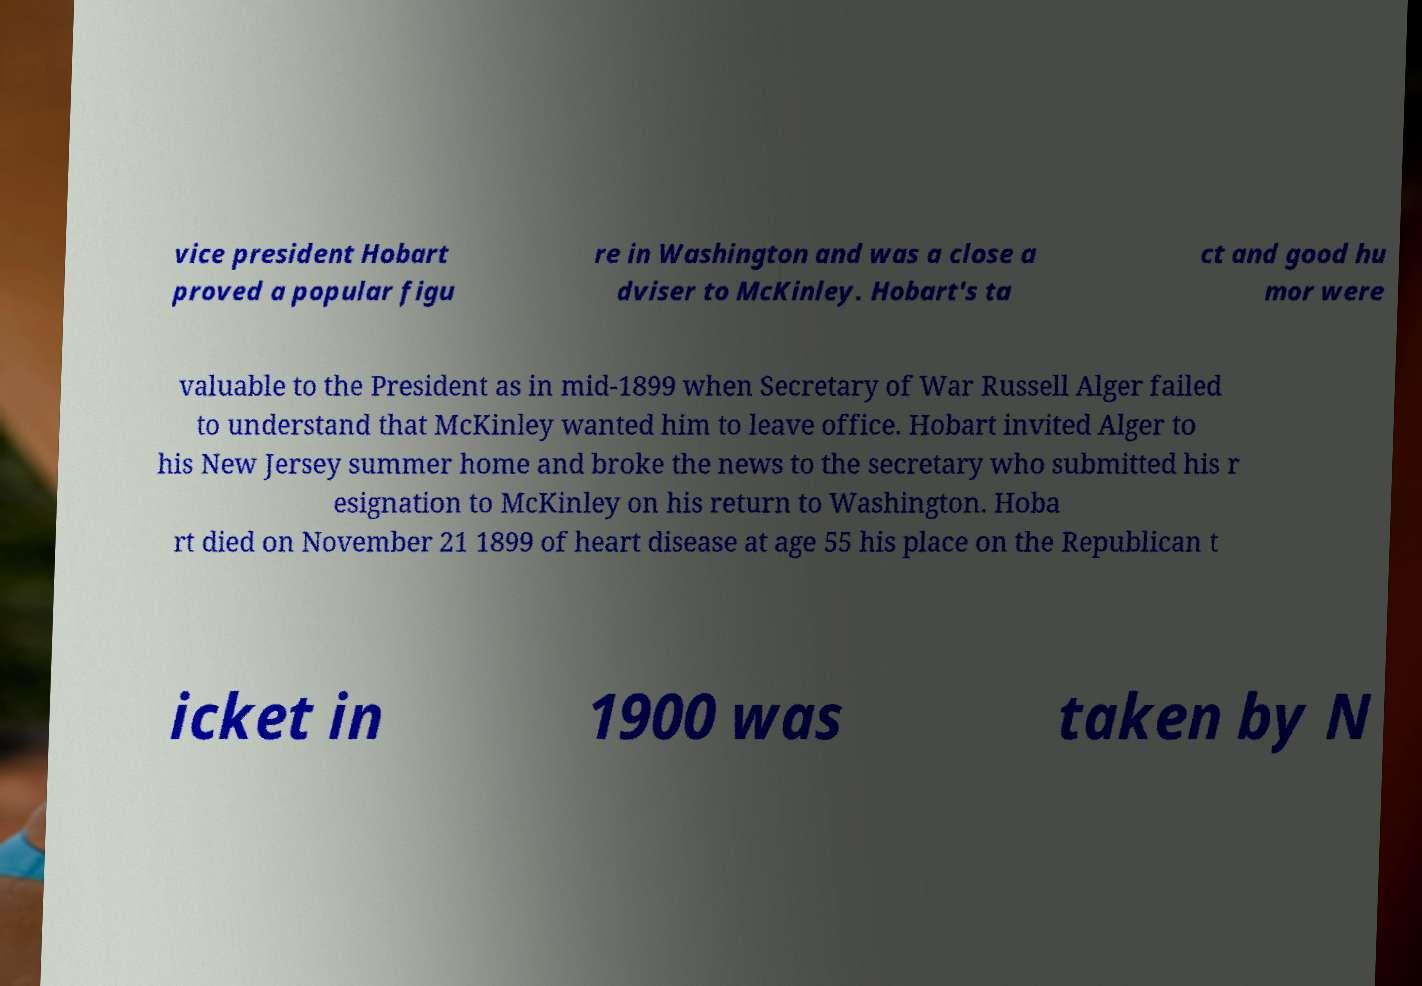Can you read and provide the text displayed in the image?This photo seems to have some interesting text. Can you extract and type it out for me? vice president Hobart proved a popular figu re in Washington and was a close a dviser to McKinley. Hobart's ta ct and good hu mor were valuable to the President as in mid-1899 when Secretary of War Russell Alger failed to understand that McKinley wanted him to leave office. Hobart invited Alger to his New Jersey summer home and broke the news to the secretary who submitted his r esignation to McKinley on his return to Washington. Hoba rt died on November 21 1899 of heart disease at age 55 his place on the Republican t icket in 1900 was taken by N 